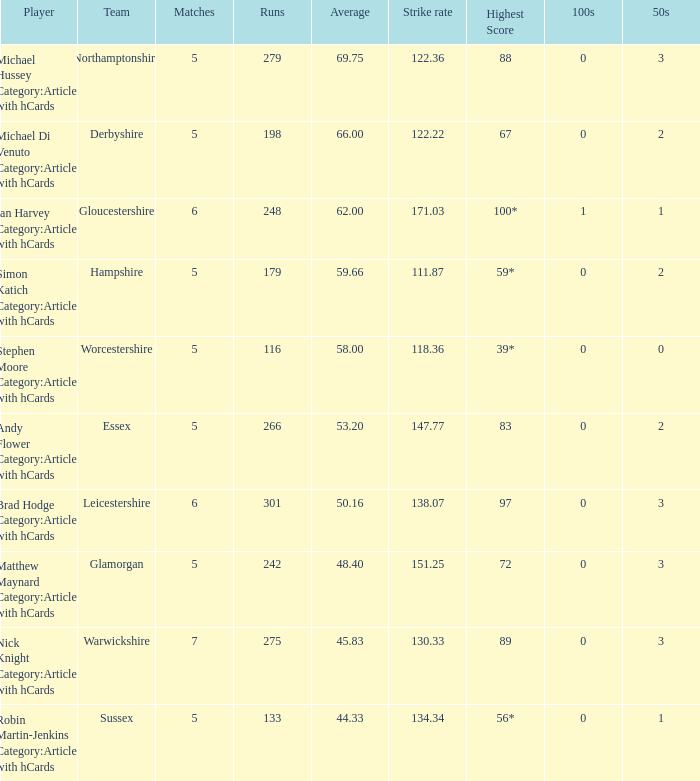If the average score is 5 Brad Hodge Category:Articles with hCards. 